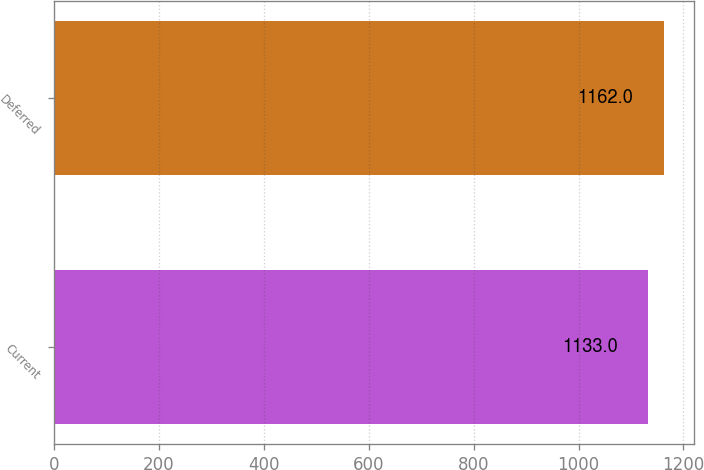<chart> <loc_0><loc_0><loc_500><loc_500><bar_chart><fcel>Current<fcel>Deferred<nl><fcel>1133<fcel>1162<nl></chart> 